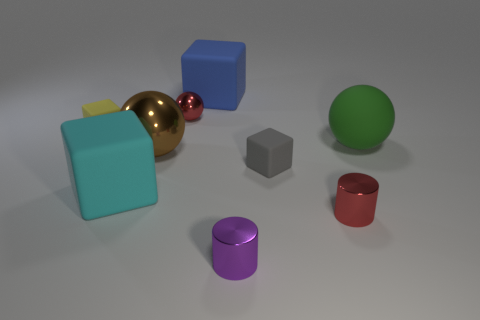What number of other objects are the same color as the tiny sphere?
Ensure brevity in your answer.  1. Does the big object that is behind the tiny red shiny sphere have the same shape as the small matte thing that is to the left of the large cyan object?
Your answer should be very brief. Yes. What number of cylinders are either small blue shiny things or big shiny things?
Make the answer very short. 0. Is the number of big rubber things on the left side of the cyan cube less than the number of big brown shiny spheres?
Offer a very short reply. Yes. How many other objects are there of the same material as the purple object?
Your answer should be very brief. 3. Does the yellow cube have the same size as the red metal cylinder?
Your response must be concise. Yes. How many things are red objects that are on the left side of the large blue block or big cyan rubber things?
Keep it short and to the point. 2. What is the big cube in front of the red object that is behind the red metallic cylinder made of?
Provide a short and direct response. Rubber. Are there any other tiny objects that have the same shape as the yellow matte object?
Keep it short and to the point. Yes. Does the blue cube have the same size as the yellow cube in front of the red metallic ball?
Provide a short and direct response. No. 